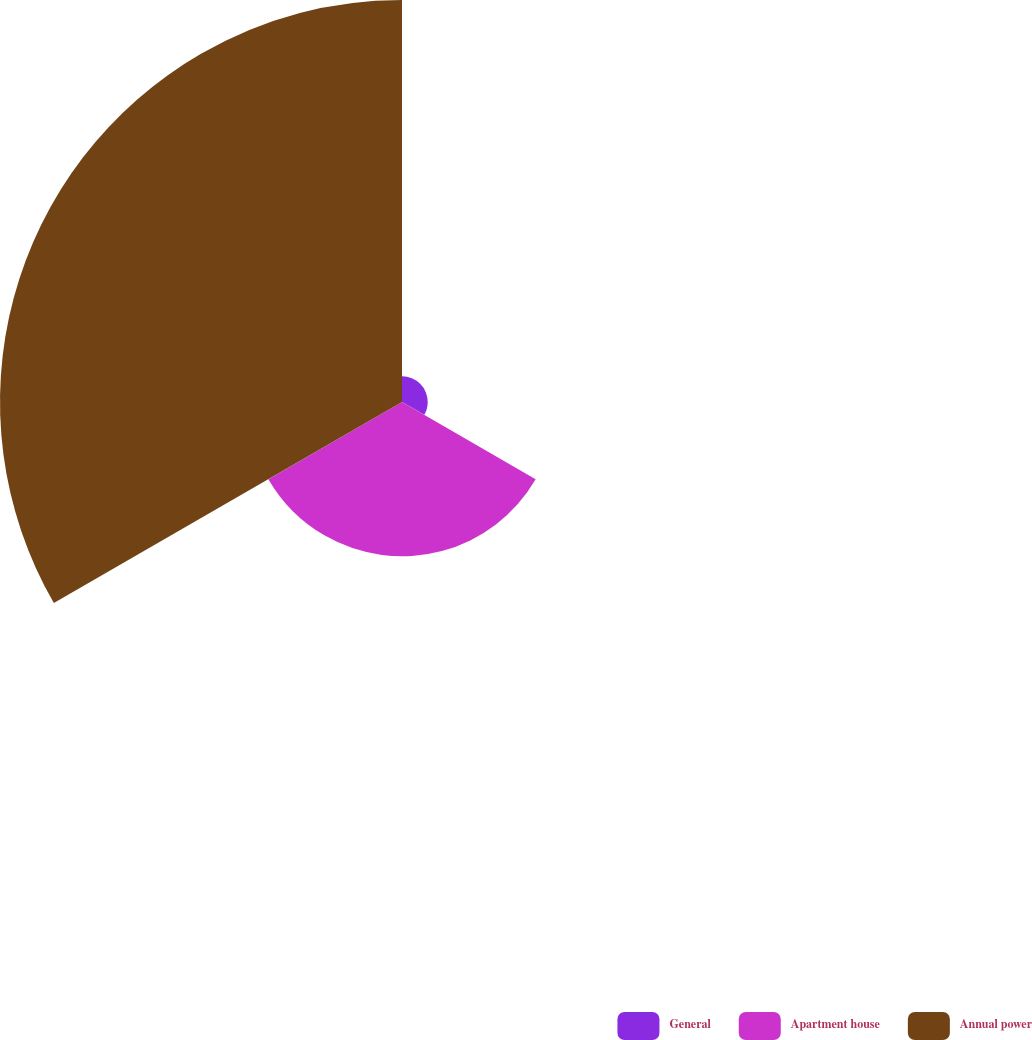Convert chart to OTSL. <chart><loc_0><loc_0><loc_500><loc_500><pie_chart><fcel>General<fcel>Apartment house<fcel>Annual power<nl><fcel>4.42%<fcel>26.51%<fcel>69.07%<nl></chart> 